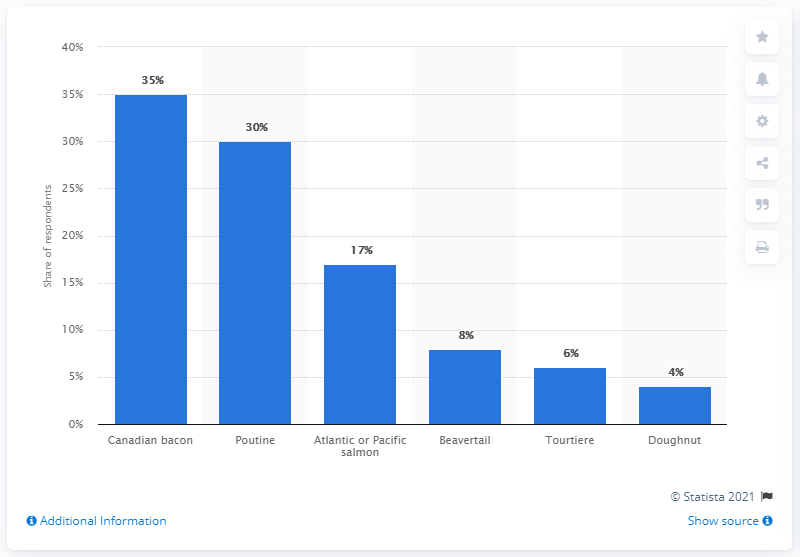Draw attention to some important aspects in this diagram. The total of at least three values is 18. Thirty-five people say Canadian bacon. 